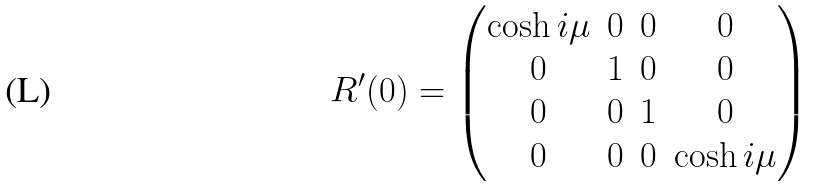<formula> <loc_0><loc_0><loc_500><loc_500>R ^ { \prime } ( 0 ) = \begin{pmatrix} \cosh i \mu & 0 & 0 & 0 \\ 0 & 1 & 0 & 0 \\ 0 & 0 & 1 & 0 \\ 0 & 0 & 0 & \cosh i \mu \\ \end{pmatrix}</formula> 